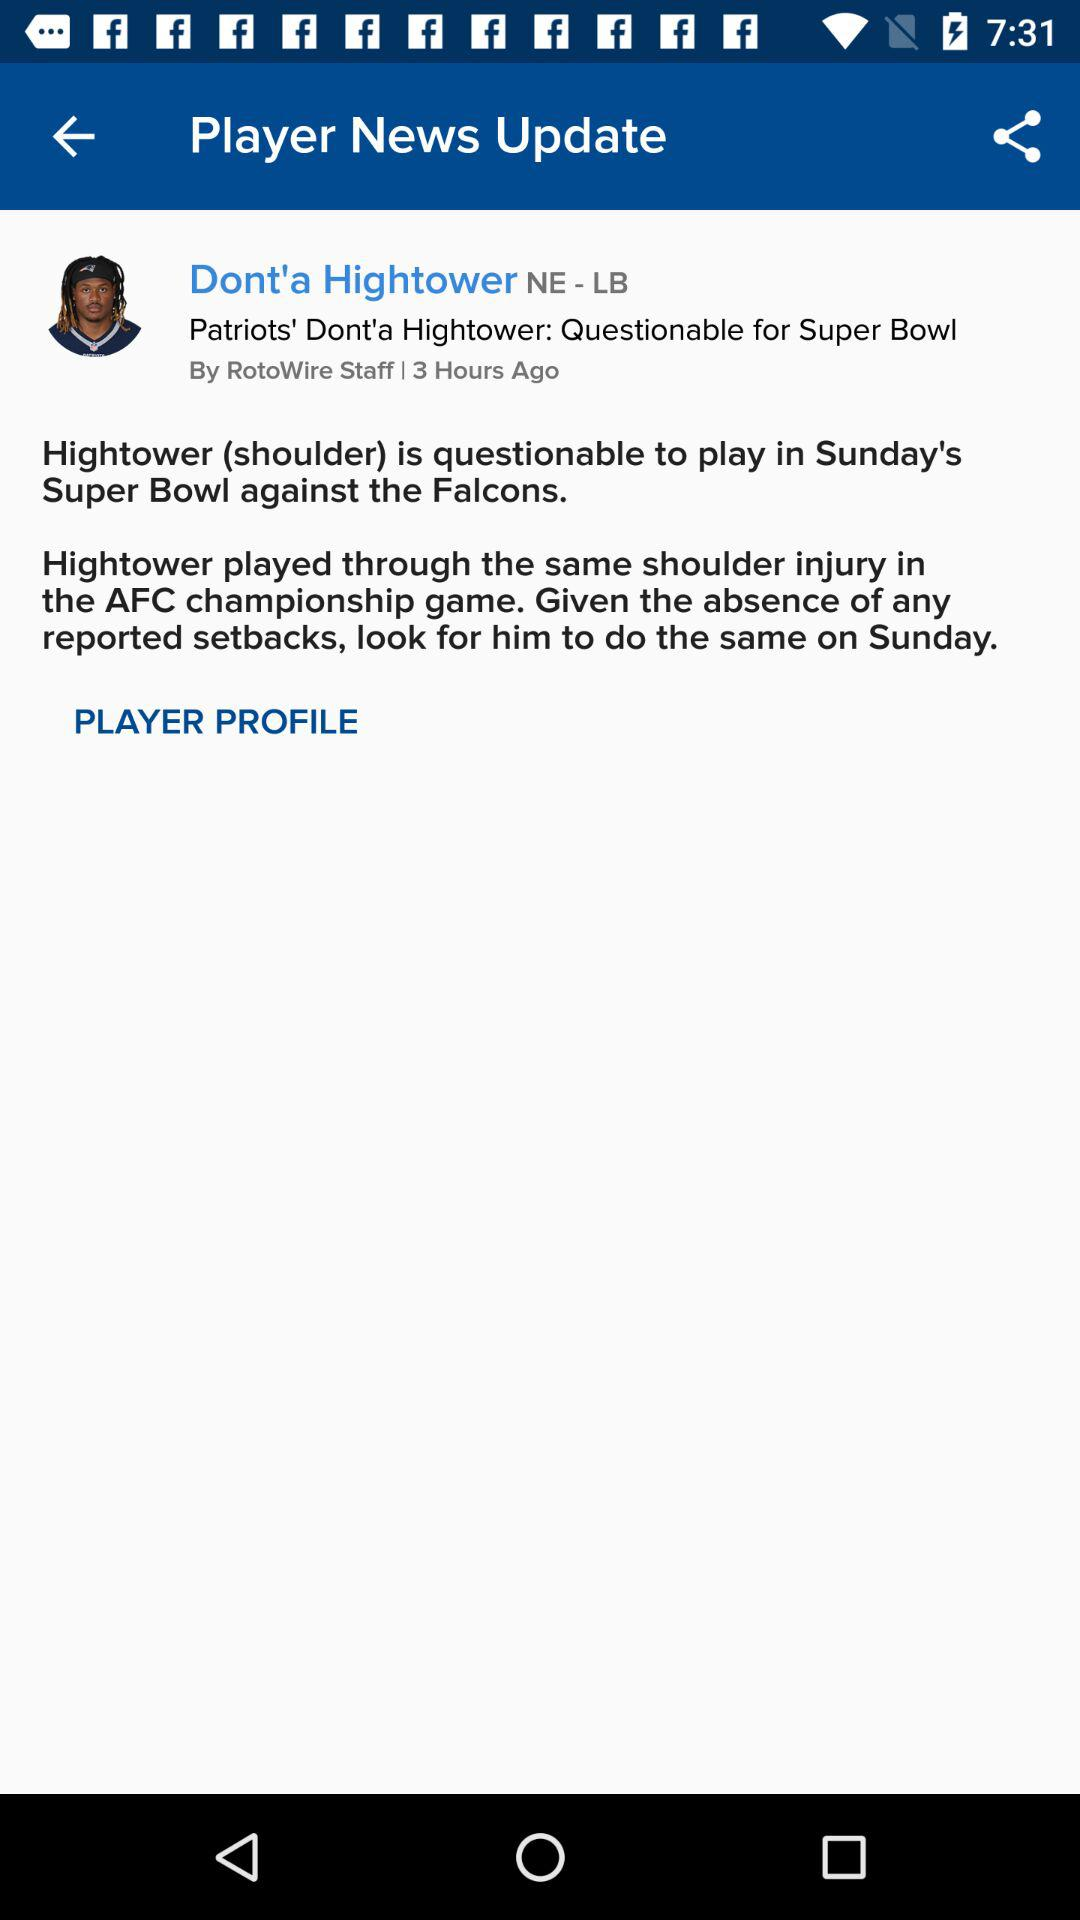How many hours ago was the article published?
Answer the question using a single word or phrase. 3 